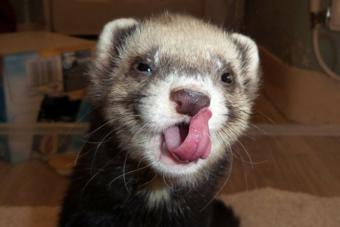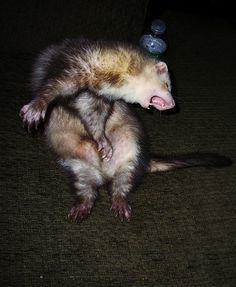The first image is the image on the left, the second image is the image on the right. Given the left and right images, does the statement "A ferret with extended tongue is visible." hold true? Answer yes or no. Yes. The first image is the image on the left, the second image is the image on the right. For the images displayed, is the sentence "Two ferrets have their mouths open." factually correct? Answer yes or no. Yes. 